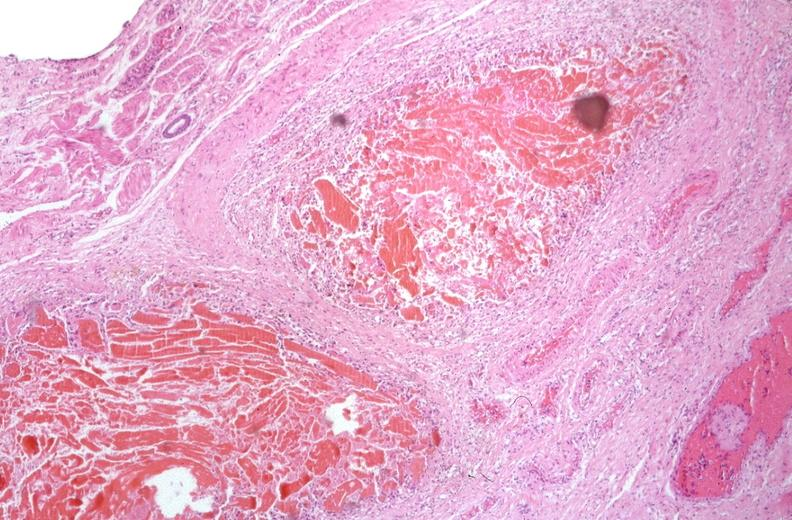where is this from?
Answer the question using a single word or phrase. Gastrointestinal system 